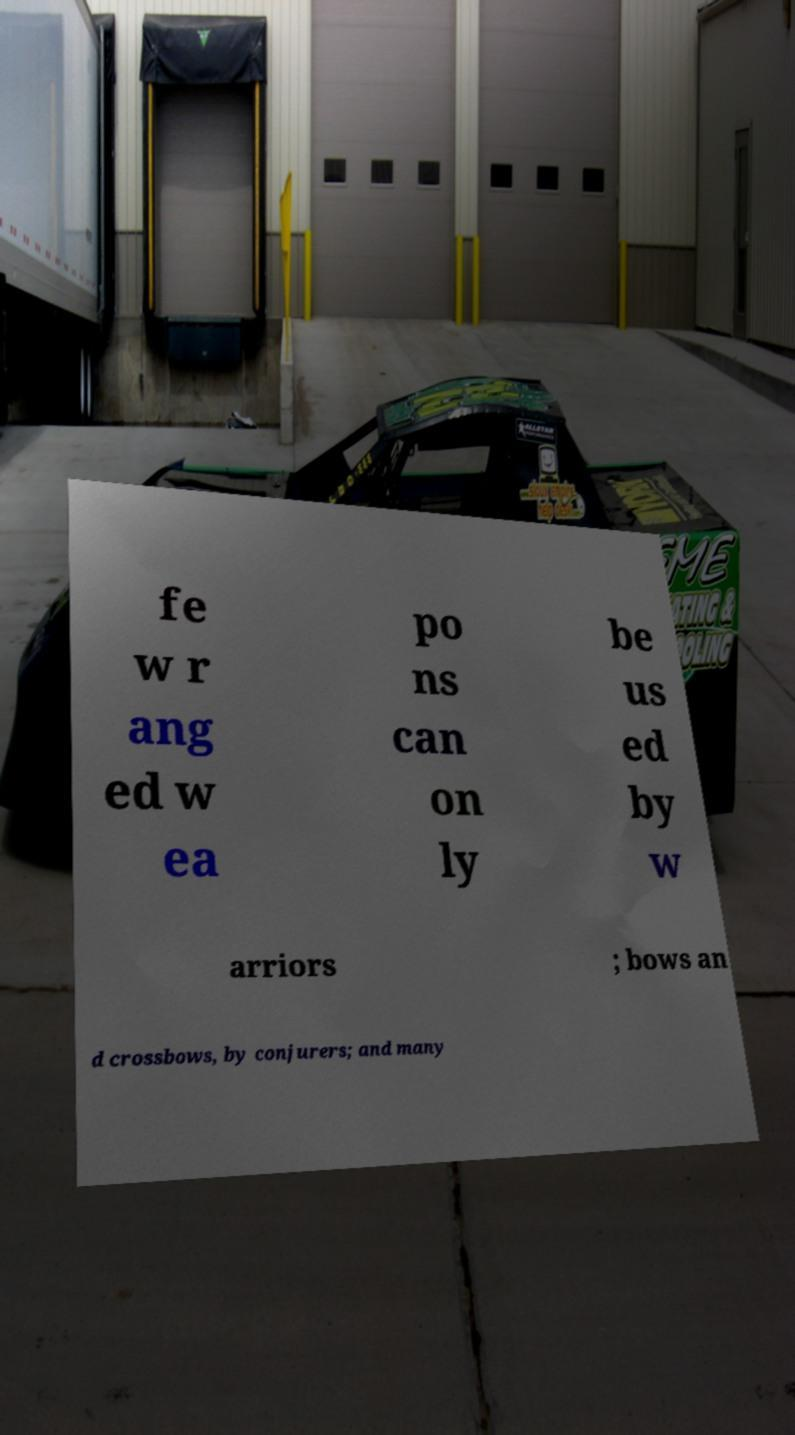What messages or text are displayed in this image? I need them in a readable, typed format. fe w r ang ed w ea po ns can on ly be us ed by w arriors ; bows an d crossbows, by conjurers; and many 